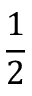<formula> <loc_0><loc_0><loc_500><loc_500>\frac { 1 } { 2 }</formula> 